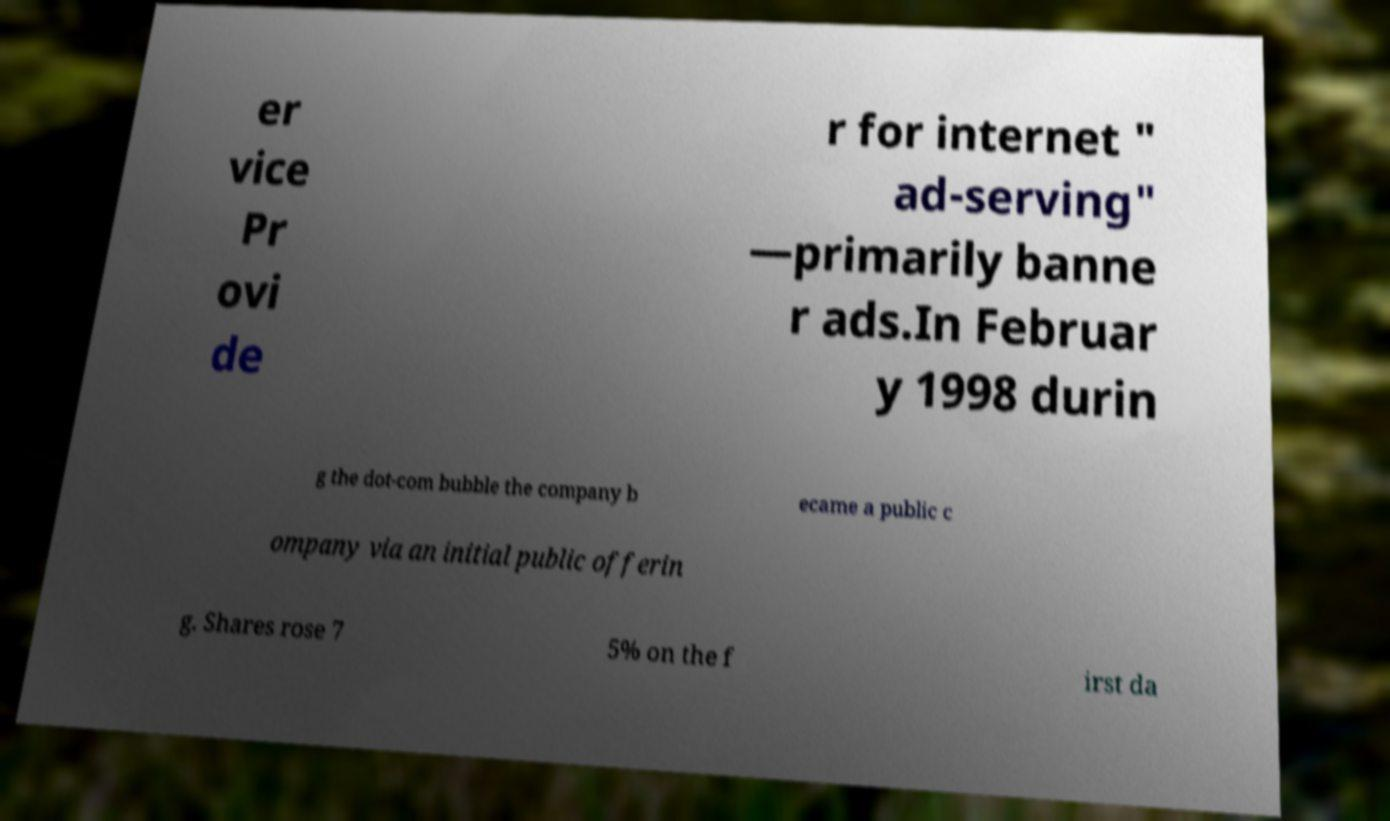Could you extract and type out the text from this image? er vice Pr ovi de r for internet " ad-serving" —primarily banne r ads.In Februar y 1998 durin g the dot-com bubble the company b ecame a public c ompany via an initial public offerin g. Shares rose 7 5% on the f irst da 